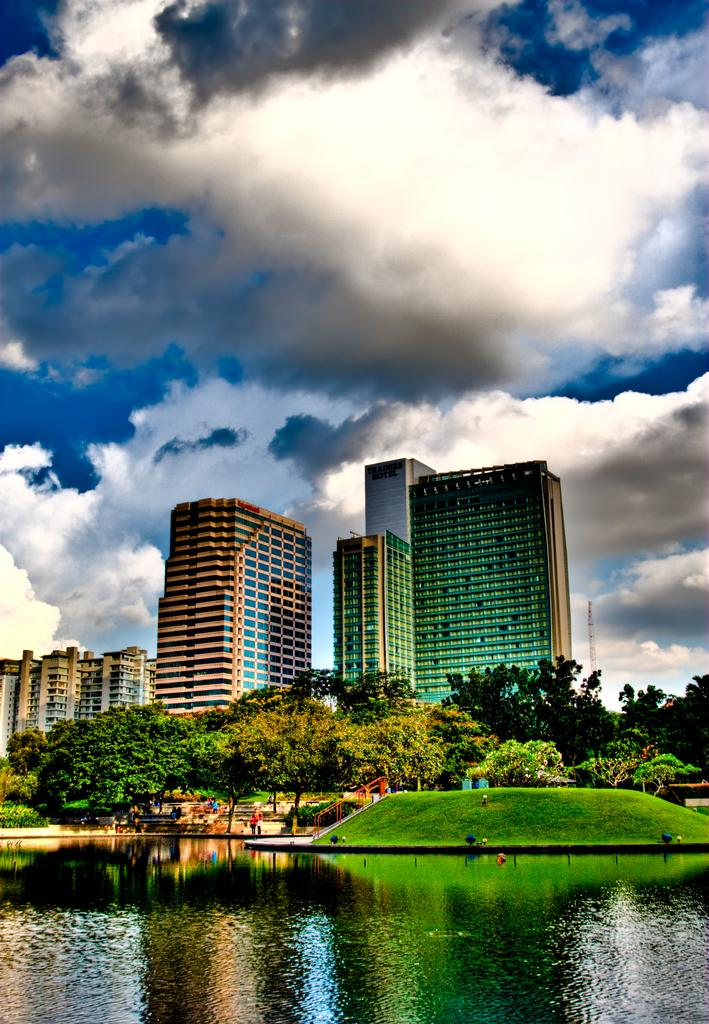What type of vegetation can be seen in the image? There are trees in the image. What natural element is visible in the image? There is water visible in the image. What type of structures are present in the image? There are buildings in the image. What type of ground cover is present in the image? There is grass in the image. What can be seen in the background of the image? The sky with clouds is visible in the background of the image. Can you see any skirts being worn by the trees in the image? There are no skirts present in the image, as trees do not wear clothing. Is there a harbor visible in the image? There is no harbor present in the image; it features trees, water, buildings, grass, and a sky with clouds. 